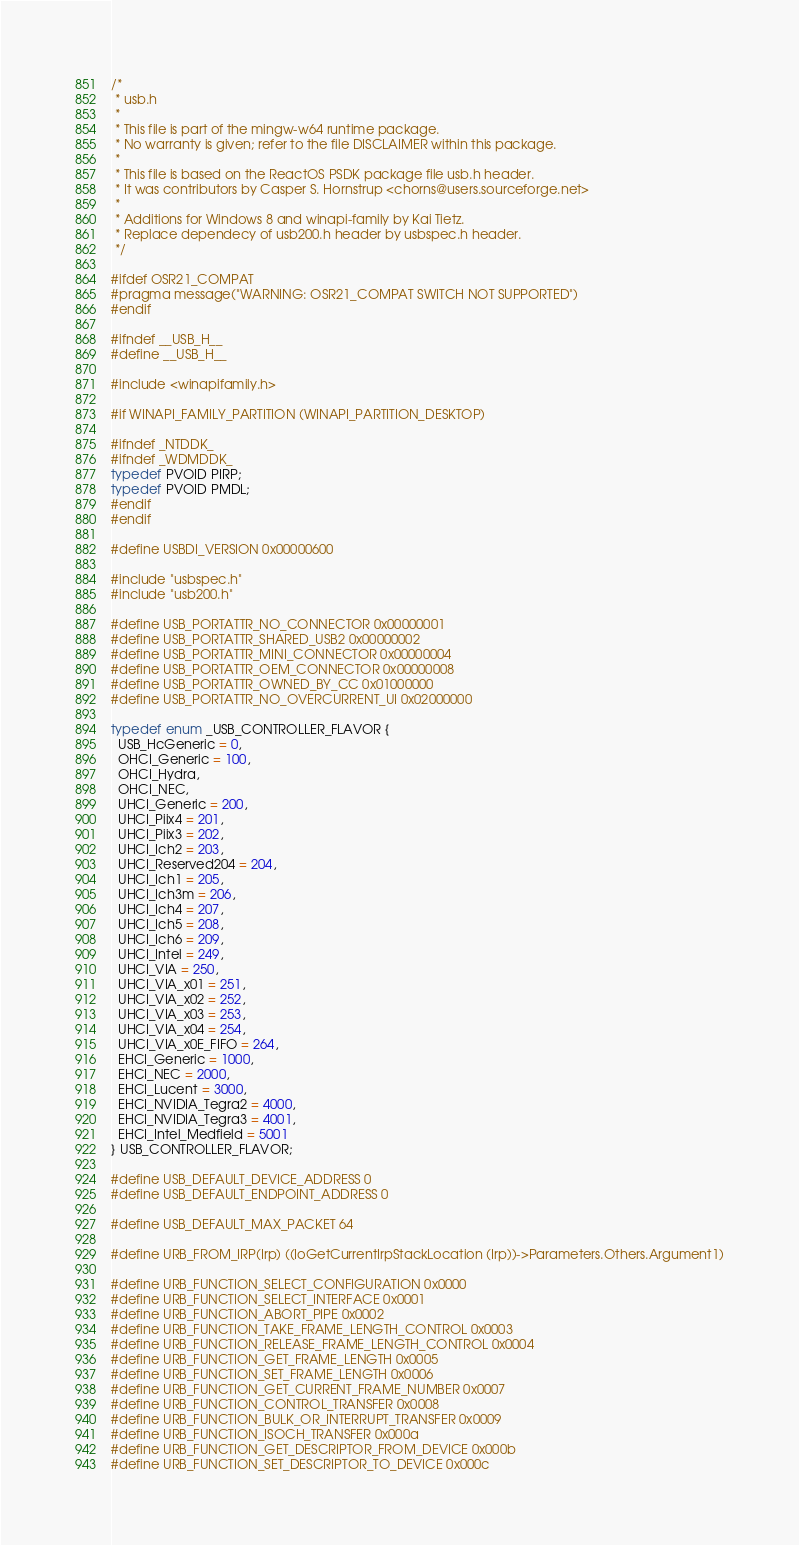Convert code to text. <code><loc_0><loc_0><loc_500><loc_500><_C_>/*
 * usb.h
 *
 * This file is part of the mingw-w64 runtime package.
 * No warranty is given; refer to the file DISCLAIMER within this package.
 *
 * This file is based on the ReactOS PSDK package file usb.h header.
 * It was contributors by Casper S. Hornstrup <chorns@users.sourceforge.net>
 *
 * Additions for Windows 8 and winapi-family by Kai Tietz.
 * Replace dependecy of usb200.h header by usbspec.h header.
 */

#ifdef OSR21_COMPAT
#pragma message("WARNING: OSR21_COMPAT SWITCH NOT SUPPORTED")
#endif

#ifndef __USB_H__
#define __USB_H__

#include <winapifamily.h>

#if WINAPI_FAMILY_PARTITION (WINAPI_PARTITION_DESKTOP)

#ifndef _NTDDK_
#ifndef _WDMDDK_
typedef PVOID PIRP;
typedef PVOID PMDL;
#endif
#endif

#define USBDI_VERSION 0x00000600

#include "usbspec.h"
#include "usb200.h"

#define USB_PORTATTR_NO_CONNECTOR 0x00000001
#define USB_PORTATTR_SHARED_USB2 0x00000002
#define USB_PORTATTR_MINI_CONNECTOR 0x00000004
#define USB_PORTATTR_OEM_CONNECTOR 0x00000008
#define USB_PORTATTR_OWNED_BY_CC 0x01000000
#define USB_PORTATTR_NO_OVERCURRENT_UI 0x02000000

typedef enum _USB_CONTROLLER_FLAVOR {
  USB_HcGeneric = 0,
  OHCI_Generic = 100,
  OHCI_Hydra,
  OHCI_NEC,
  UHCI_Generic = 200,
  UHCI_Piix4 = 201,
  UHCI_Piix3 = 202,
  UHCI_Ich2 = 203,
  UHCI_Reserved204 = 204,
  UHCI_Ich1 = 205,
  UHCI_Ich3m = 206,
  UHCI_Ich4 = 207,
  UHCI_Ich5 = 208,
  UHCI_Ich6 = 209,
  UHCI_Intel = 249,
  UHCI_VIA = 250,
  UHCI_VIA_x01 = 251,
  UHCI_VIA_x02 = 252,
  UHCI_VIA_x03 = 253,
  UHCI_VIA_x04 = 254,
  UHCI_VIA_x0E_FIFO = 264,
  EHCI_Generic = 1000,
  EHCI_NEC = 2000,
  EHCI_Lucent = 3000,
  EHCI_NVIDIA_Tegra2 = 4000,
  EHCI_NVIDIA_Tegra3 = 4001,
  EHCI_Intel_Medfield = 5001
} USB_CONTROLLER_FLAVOR;

#define USB_DEFAULT_DEVICE_ADDRESS 0
#define USB_DEFAULT_ENDPOINT_ADDRESS 0

#define USB_DEFAULT_MAX_PACKET 64

#define URB_FROM_IRP(Irp) ((IoGetCurrentIrpStackLocation (Irp))->Parameters.Others.Argument1)

#define URB_FUNCTION_SELECT_CONFIGURATION 0x0000
#define URB_FUNCTION_SELECT_INTERFACE 0x0001
#define URB_FUNCTION_ABORT_PIPE 0x0002
#define URB_FUNCTION_TAKE_FRAME_LENGTH_CONTROL 0x0003
#define URB_FUNCTION_RELEASE_FRAME_LENGTH_CONTROL 0x0004
#define URB_FUNCTION_GET_FRAME_LENGTH 0x0005
#define URB_FUNCTION_SET_FRAME_LENGTH 0x0006
#define URB_FUNCTION_GET_CURRENT_FRAME_NUMBER 0x0007
#define URB_FUNCTION_CONTROL_TRANSFER 0x0008
#define URB_FUNCTION_BULK_OR_INTERRUPT_TRANSFER 0x0009
#define URB_FUNCTION_ISOCH_TRANSFER 0x000a
#define URB_FUNCTION_GET_DESCRIPTOR_FROM_DEVICE 0x000b
#define URB_FUNCTION_SET_DESCRIPTOR_TO_DEVICE 0x000c</code> 